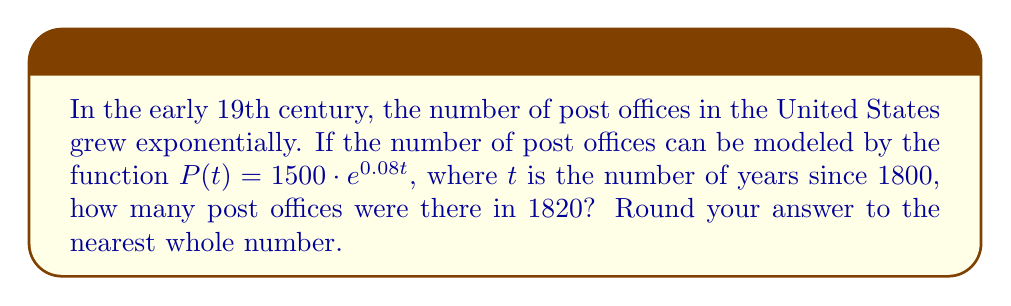Show me your answer to this math problem. To solve this problem, we'll follow these steps:

1. Identify the given information:
   - The function modeling the number of post offices is $P(t) = 1500 \cdot e^{0.08t}$
   - $t$ represents the number of years since 1800
   - We need to find the number of post offices in 1820

2. Calculate the value of $t$ for the year 1820:
   $t = 1820 - 1800 = 20$ years

3. Substitute $t = 20$ into the function:
   $P(20) = 1500 \cdot e^{0.08 \cdot 20}$

4. Simplify the exponent:
   $P(20) = 1500 \cdot e^{1.6}$

5. Calculate the value using a calculator:
   $P(20) = 1500 \cdot 4.95303...$
   $P(20) = 7,429.54...$

6. Round to the nearest whole number:
   $P(20) \approx 7,430$

Therefore, according to this model, there were approximately 7,430 post offices in 1820.
Answer: 7,430 post offices 